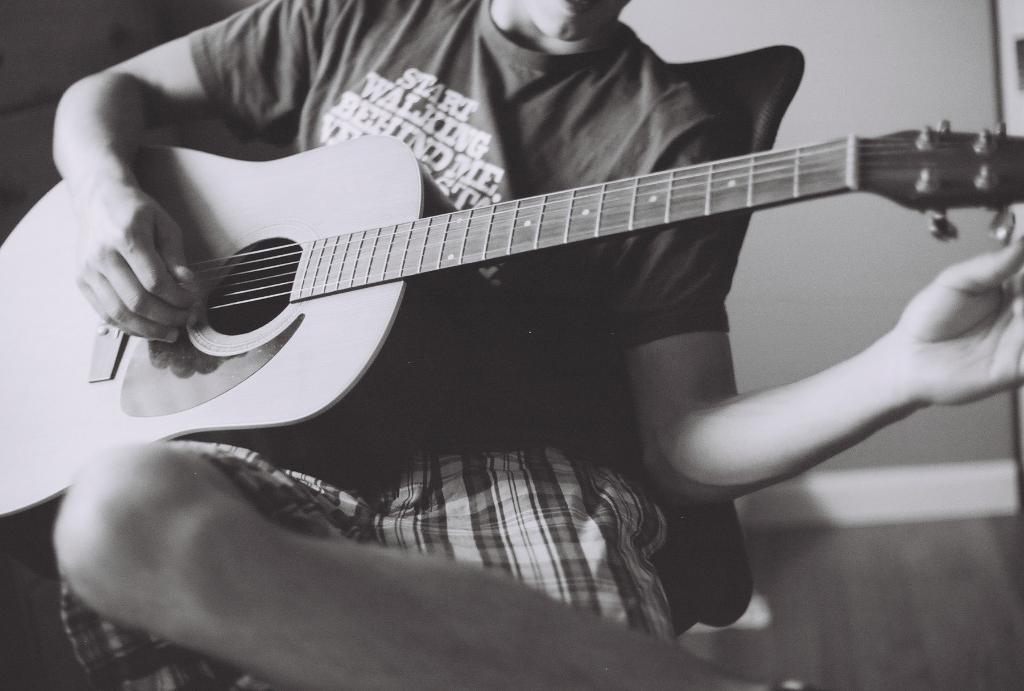What is the main subject of the image? There is a guy in the image. What is the guy doing in the image? The guy is playing a guitar. What is the guy sitting on in the image? The guy is sitting on a chair. What is the guy's dad doing in the image? There is no mention of the guy's dad in the image, so it cannot be determined what he might be doing. 